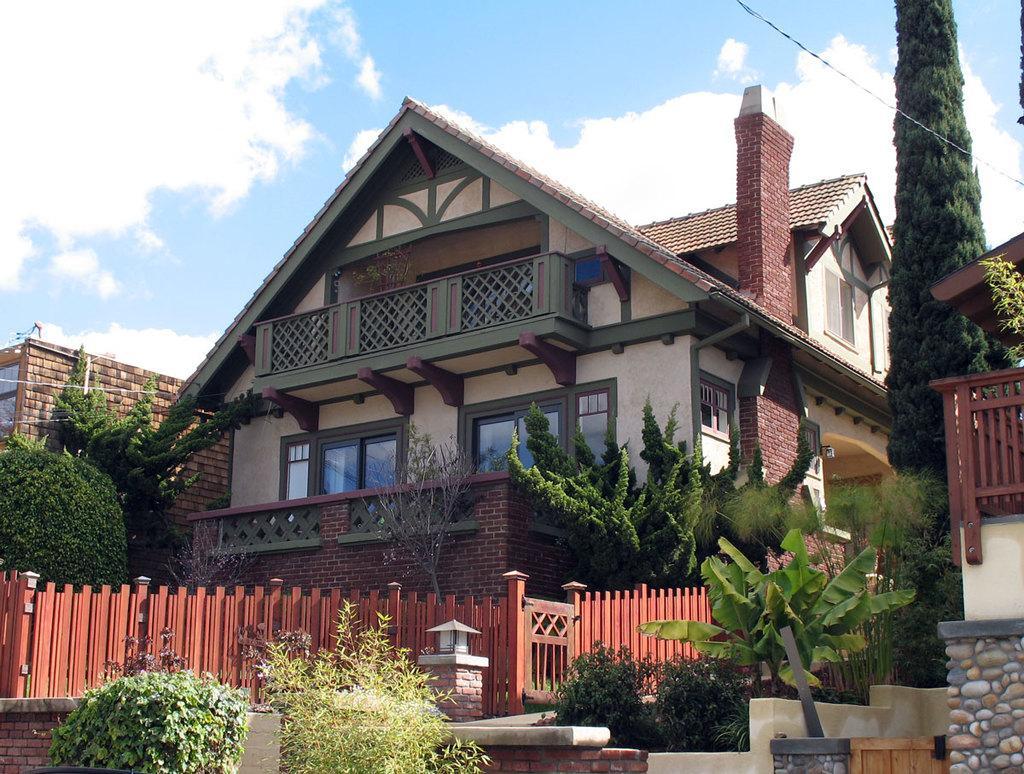Describe this image in one or two sentences. There is a building with windows and balcony. Near to the building there are many trees. Also there is a compound wall. In the background there is sky with clouds. And there are brick walls. 